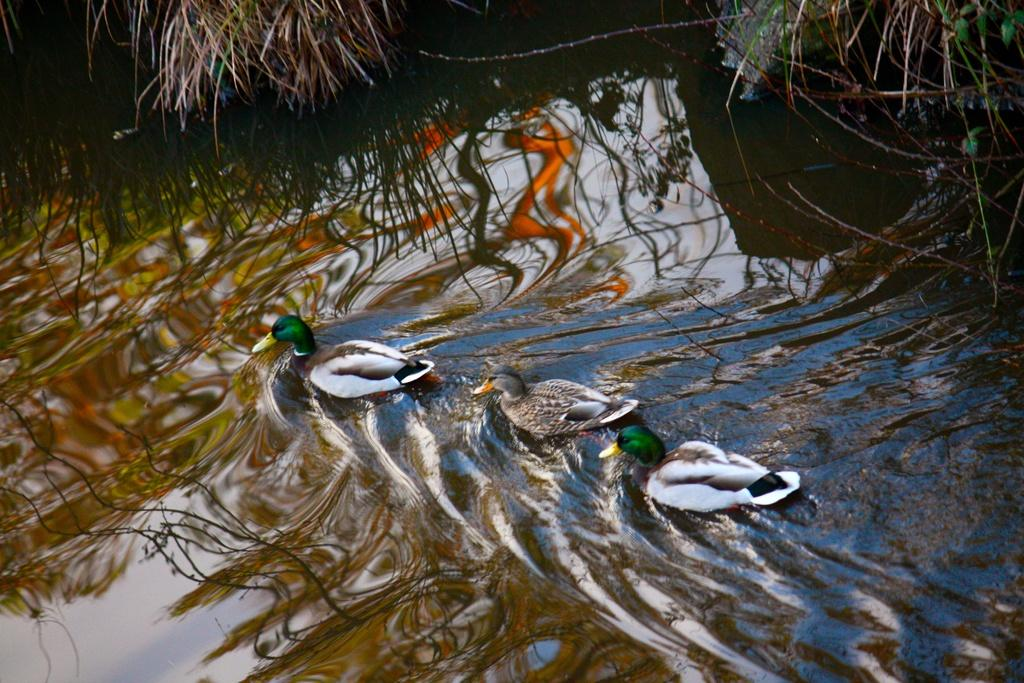How many ducks are in the water in the image? There are three ducks in the water in the image. What else can be seen in the image besides the ducks? Plants are visible at the top of the image. What type of hammer can be seen in the image? There is no hammer present in the image. 